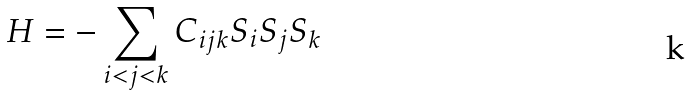<formula> <loc_0><loc_0><loc_500><loc_500>H = - \sum _ { i < j < k } C _ { i j k } S _ { i } S _ { j } S _ { k }</formula> 